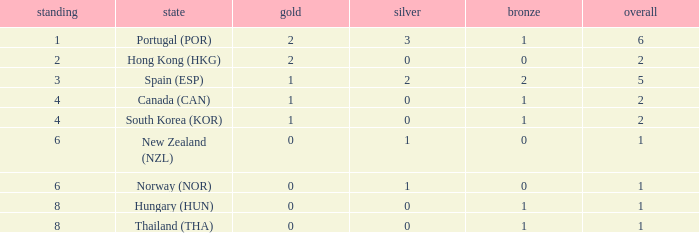What is the lowest Total containing a Bronze of 0 and Rank smaller than 2? None. 